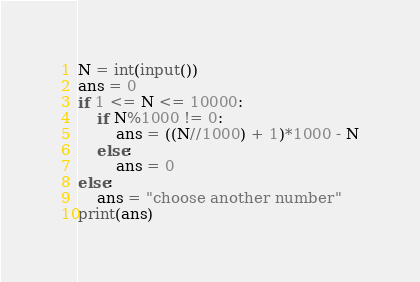<code> <loc_0><loc_0><loc_500><loc_500><_Python_>N = int(input())
ans = 0
if 1 <= N <= 10000:
    if N%1000 != 0:
        ans = ((N//1000) + 1)*1000 - N
    else:
        ans = 0
else:
    ans = "choose another number"
print(ans)</code> 